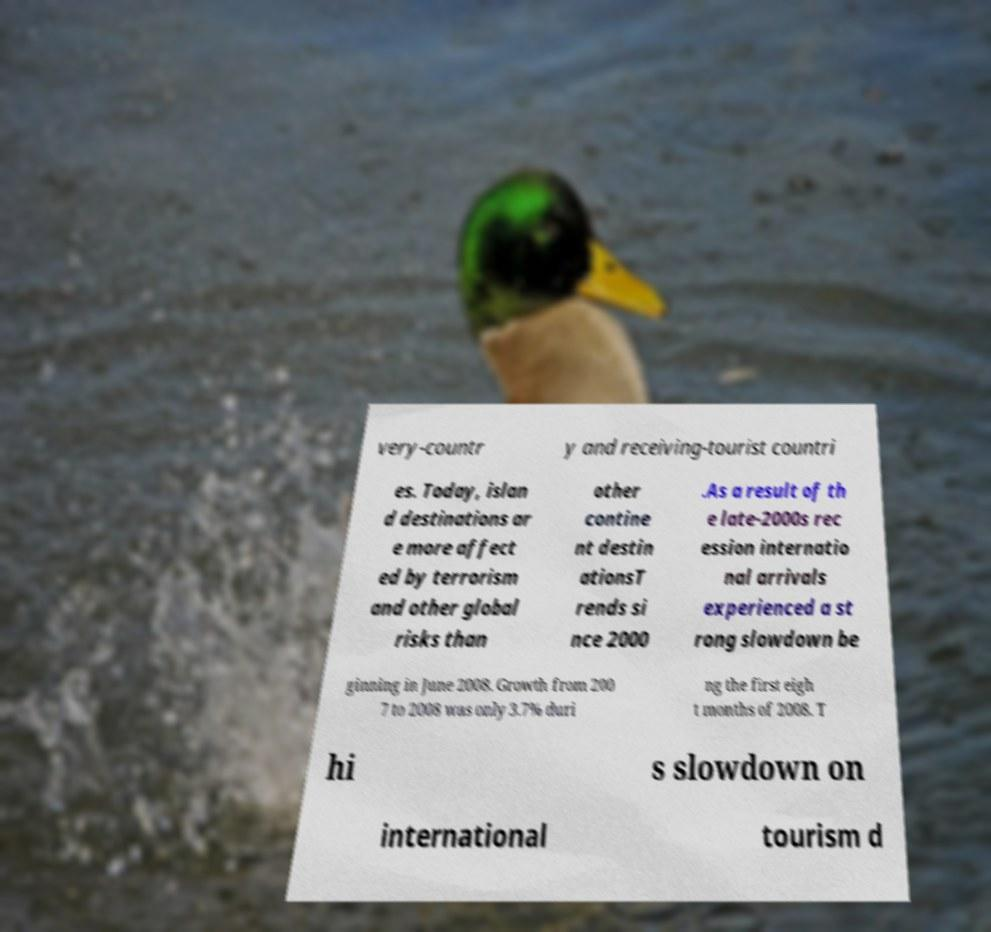Can you accurately transcribe the text from the provided image for me? very-countr y and receiving-tourist countri es. Today, islan d destinations ar e more affect ed by terrorism and other global risks than other contine nt destin ationsT rends si nce 2000 .As a result of th e late-2000s rec ession internatio nal arrivals experienced a st rong slowdown be ginning in June 2008. Growth from 200 7 to 2008 was only 3.7% duri ng the first eigh t months of 2008. T hi s slowdown on international tourism d 